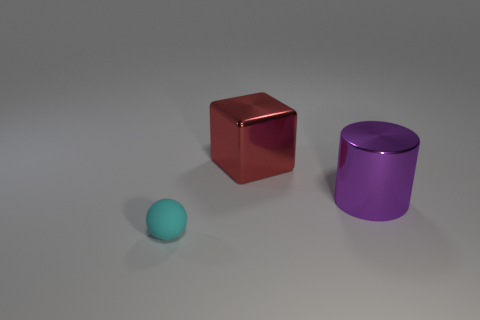Add 1 rubber things. How many objects exist? 4 Subtract all blocks. How many objects are left? 2 Subtract all big blocks. Subtract all big metallic things. How many objects are left? 0 Add 3 small cyan matte things. How many small cyan matte things are left? 4 Add 2 tiny yellow shiny blocks. How many tiny yellow shiny blocks exist? 2 Subtract 0 yellow cylinders. How many objects are left? 3 